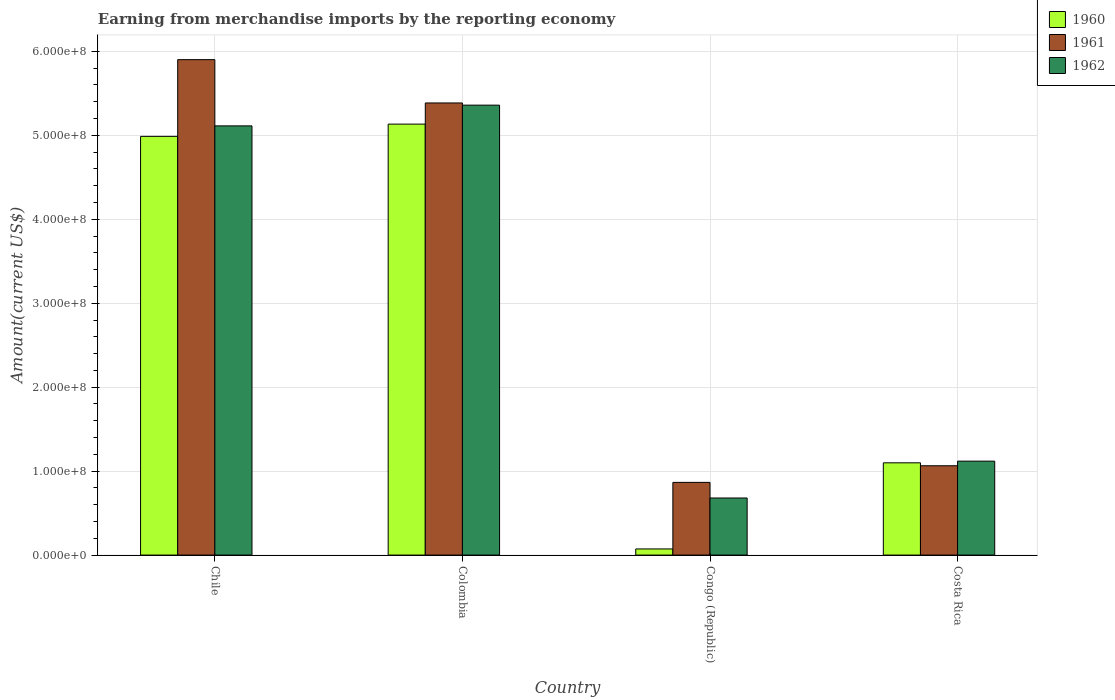How many bars are there on the 3rd tick from the left?
Provide a succinct answer. 3. What is the label of the 1st group of bars from the left?
Ensure brevity in your answer.  Chile. In how many cases, is the number of bars for a given country not equal to the number of legend labels?
Give a very brief answer. 0. What is the amount earned from merchandise imports in 1962 in Congo (Republic)?
Give a very brief answer. 6.80e+07. Across all countries, what is the maximum amount earned from merchandise imports in 1962?
Make the answer very short. 5.36e+08. Across all countries, what is the minimum amount earned from merchandise imports in 1962?
Offer a very short reply. 6.80e+07. In which country was the amount earned from merchandise imports in 1961 maximum?
Ensure brevity in your answer.  Chile. In which country was the amount earned from merchandise imports in 1962 minimum?
Offer a very short reply. Congo (Republic). What is the total amount earned from merchandise imports in 1962 in the graph?
Provide a short and direct response. 1.23e+09. What is the difference between the amount earned from merchandise imports in 1960 in Congo (Republic) and that in Costa Rica?
Offer a terse response. -1.03e+08. What is the difference between the amount earned from merchandise imports in 1962 in Costa Rica and the amount earned from merchandise imports in 1960 in Chile?
Offer a very short reply. -3.87e+08. What is the average amount earned from merchandise imports in 1961 per country?
Give a very brief answer. 3.30e+08. What is the difference between the amount earned from merchandise imports of/in 1962 and amount earned from merchandise imports of/in 1961 in Chile?
Keep it short and to the point. -7.89e+07. What is the ratio of the amount earned from merchandise imports in 1960 in Congo (Republic) to that in Costa Rica?
Ensure brevity in your answer.  0.07. Is the amount earned from merchandise imports in 1962 in Colombia less than that in Congo (Republic)?
Give a very brief answer. No. What is the difference between the highest and the second highest amount earned from merchandise imports in 1962?
Make the answer very short. 4.24e+08. What is the difference between the highest and the lowest amount earned from merchandise imports in 1962?
Provide a short and direct response. 4.68e+08. Is the sum of the amount earned from merchandise imports in 1960 in Colombia and Costa Rica greater than the maximum amount earned from merchandise imports in 1961 across all countries?
Give a very brief answer. Yes. What does the 1st bar from the left in Congo (Republic) represents?
Offer a terse response. 1960. What does the 2nd bar from the right in Chile represents?
Your answer should be compact. 1961. Is it the case that in every country, the sum of the amount earned from merchandise imports in 1961 and amount earned from merchandise imports in 1962 is greater than the amount earned from merchandise imports in 1960?
Make the answer very short. Yes. How many bars are there?
Give a very brief answer. 12. How many countries are there in the graph?
Make the answer very short. 4. Are the values on the major ticks of Y-axis written in scientific E-notation?
Make the answer very short. Yes. Does the graph contain grids?
Offer a terse response. Yes. How many legend labels are there?
Make the answer very short. 3. What is the title of the graph?
Keep it short and to the point. Earning from merchandise imports by the reporting economy. Does "1966" appear as one of the legend labels in the graph?
Provide a succinct answer. No. What is the label or title of the X-axis?
Make the answer very short. Country. What is the label or title of the Y-axis?
Make the answer very short. Amount(current US$). What is the Amount(current US$) in 1960 in Chile?
Your response must be concise. 4.99e+08. What is the Amount(current US$) of 1961 in Chile?
Keep it short and to the point. 5.90e+08. What is the Amount(current US$) in 1962 in Chile?
Make the answer very short. 5.11e+08. What is the Amount(current US$) in 1960 in Colombia?
Provide a succinct answer. 5.13e+08. What is the Amount(current US$) in 1961 in Colombia?
Your answer should be compact. 5.39e+08. What is the Amount(current US$) of 1962 in Colombia?
Make the answer very short. 5.36e+08. What is the Amount(current US$) in 1960 in Congo (Republic)?
Keep it short and to the point. 7.30e+06. What is the Amount(current US$) of 1961 in Congo (Republic)?
Provide a succinct answer. 8.66e+07. What is the Amount(current US$) of 1962 in Congo (Republic)?
Your answer should be compact. 6.80e+07. What is the Amount(current US$) in 1960 in Costa Rica?
Keep it short and to the point. 1.10e+08. What is the Amount(current US$) of 1961 in Costa Rica?
Ensure brevity in your answer.  1.06e+08. What is the Amount(current US$) in 1962 in Costa Rica?
Make the answer very short. 1.12e+08. Across all countries, what is the maximum Amount(current US$) of 1960?
Your response must be concise. 5.13e+08. Across all countries, what is the maximum Amount(current US$) of 1961?
Make the answer very short. 5.90e+08. Across all countries, what is the maximum Amount(current US$) in 1962?
Your answer should be compact. 5.36e+08. Across all countries, what is the minimum Amount(current US$) in 1960?
Make the answer very short. 7.30e+06. Across all countries, what is the minimum Amount(current US$) in 1961?
Your answer should be very brief. 8.66e+07. Across all countries, what is the minimum Amount(current US$) of 1962?
Your answer should be compact. 6.80e+07. What is the total Amount(current US$) in 1960 in the graph?
Your response must be concise. 1.13e+09. What is the total Amount(current US$) of 1961 in the graph?
Offer a terse response. 1.32e+09. What is the total Amount(current US$) of 1962 in the graph?
Your response must be concise. 1.23e+09. What is the difference between the Amount(current US$) of 1960 in Chile and that in Colombia?
Ensure brevity in your answer.  -1.46e+07. What is the difference between the Amount(current US$) of 1961 in Chile and that in Colombia?
Ensure brevity in your answer.  5.16e+07. What is the difference between the Amount(current US$) in 1962 in Chile and that in Colombia?
Ensure brevity in your answer.  -2.47e+07. What is the difference between the Amount(current US$) in 1960 in Chile and that in Congo (Republic)?
Provide a succinct answer. 4.92e+08. What is the difference between the Amount(current US$) of 1961 in Chile and that in Congo (Republic)?
Your answer should be very brief. 5.04e+08. What is the difference between the Amount(current US$) of 1962 in Chile and that in Congo (Republic)?
Give a very brief answer. 4.43e+08. What is the difference between the Amount(current US$) of 1960 in Chile and that in Costa Rica?
Your answer should be very brief. 3.89e+08. What is the difference between the Amount(current US$) of 1961 in Chile and that in Costa Rica?
Give a very brief answer. 4.84e+08. What is the difference between the Amount(current US$) in 1962 in Chile and that in Costa Rica?
Your answer should be very brief. 3.99e+08. What is the difference between the Amount(current US$) in 1960 in Colombia and that in Congo (Republic)?
Your answer should be compact. 5.06e+08. What is the difference between the Amount(current US$) of 1961 in Colombia and that in Congo (Republic)?
Keep it short and to the point. 4.52e+08. What is the difference between the Amount(current US$) of 1962 in Colombia and that in Congo (Republic)?
Offer a very short reply. 4.68e+08. What is the difference between the Amount(current US$) of 1960 in Colombia and that in Costa Rica?
Provide a succinct answer. 4.04e+08. What is the difference between the Amount(current US$) of 1961 in Colombia and that in Costa Rica?
Your response must be concise. 4.32e+08. What is the difference between the Amount(current US$) of 1962 in Colombia and that in Costa Rica?
Offer a very short reply. 4.24e+08. What is the difference between the Amount(current US$) of 1960 in Congo (Republic) and that in Costa Rica?
Ensure brevity in your answer.  -1.03e+08. What is the difference between the Amount(current US$) of 1961 in Congo (Republic) and that in Costa Rica?
Your response must be concise. -1.98e+07. What is the difference between the Amount(current US$) in 1962 in Congo (Republic) and that in Costa Rica?
Offer a very short reply. -4.39e+07. What is the difference between the Amount(current US$) in 1960 in Chile and the Amount(current US$) in 1961 in Colombia?
Offer a terse response. -3.98e+07. What is the difference between the Amount(current US$) of 1960 in Chile and the Amount(current US$) of 1962 in Colombia?
Your response must be concise. -3.72e+07. What is the difference between the Amount(current US$) in 1961 in Chile and the Amount(current US$) in 1962 in Colombia?
Make the answer very short. 5.42e+07. What is the difference between the Amount(current US$) in 1960 in Chile and the Amount(current US$) in 1961 in Congo (Republic)?
Provide a succinct answer. 4.12e+08. What is the difference between the Amount(current US$) in 1960 in Chile and the Amount(current US$) in 1962 in Congo (Republic)?
Provide a short and direct response. 4.31e+08. What is the difference between the Amount(current US$) in 1961 in Chile and the Amount(current US$) in 1962 in Congo (Republic)?
Offer a terse response. 5.22e+08. What is the difference between the Amount(current US$) in 1960 in Chile and the Amount(current US$) in 1961 in Costa Rica?
Give a very brief answer. 3.92e+08. What is the difference between the Amount(current US$) in 1960 in Chile and the Amount(current US$) in 1962 in Costa Rica?
Provide a short and direct response. 3.87e+08. What is the difference between the Amount(current US$) of 1961 in Chile and the Amount(current US$) of 1962 in Costa Rica?
Your answer should be compact. 4.78e+08. What is the difference between the Amount(current US$) of 1960 in Colombia and the Amount(current US$) of 1961 in Congo (Republic)?
Give a very brief answer. 4.27e+08. What is the difference between the Amount(current US$) in 1960 in Colombia and the Amount(current US$) in 1962 in Congo (Republic)?
Your answer should be very brief. 4.45e+08. What is the difference between the Amount(current US$) of 1961 in Colombia and the Amount(current US$) of 1962 in Congo (Republic)?
Offer a terse response. 4.71e+08. What is the difference between the Amount(current US$) of 1960 in Colombia and the Amount(current US$) of 1961 in Costa Rica?
Make the answer very short. 4.07e+08. What is the difference between the Amount(current US$) in 1960 in Colombia and the Amount(current US$) in 1962 in Costa Rica?
Offer a terse response. 4.02e+08. What is the difference between the Amount(current US$) of 1961 in Colombia and the Amount(current US$) of 1962 in Costa Rica?
Make the answer very short. 4.27e+08. What is the difference between the Amount(current US$) of 1960 in Congo (Republic) and the Amount(current US$) of 1961 in Costa Rica?
Your answer should be compact. -9.91e+07. What is the difference between the Amount(current US$) in 1960 in Congo (Republic) and the Amount(current US$) in 1962 in Costa Rica?
Offer a terse response. -1.05e+08. What is the difference between the Amount(current US$) of 1961 in Congo (Republic) and the Amount(current US$) of 1962 in Costa Rica?
Offer a very short reply. -2.53e+07. What is the average Amount(current US$) of 1960 per country?
Give a very brief answer. 2.82e+08. What is the average Amount(current US$) in 1961 per country?
Provide a succinct answer. 3.30e+08. What is the average Amount(current US$) of 1962 per country?
Provide a short and direct response. 3.07e+08. What is the difference between the Amount(current US$) of 1960 and Amount(current US$) of 1961 in Chile?
Provide a succinct answer. -9.14e+07. What is the difference between the Amount(current US$) in 1960 and Amount(current US$) in 1962 in Chile?
Offer a very short reply. -1.25e+07. What is the difference between the Amount(current US$) of 1961 and Amount(current US$) of 1962 in Chile?
Your answer should be compact. 7.89e+07. What is the difference between the Amount(current US$) in 1960 and Amount(current US$) in 1961 in Colombia?
Your response must be concise. -2.52e+07. What is the difference between the Amount(current US$) in 1960 and Amount(current US$) in 1962 in Colombia?
Your response must be concise. -2.26e+07. What is the difference between the Amount(current US$) of 1961 and Amount(current US$) of 1962 in Colombia?
Your answer should be compact. 2.60e+06. What is the difference between the Amount(current US$) in 1960 and Amount(current US$) in 1961 in Congo (Republic)?
Your answer should be compact. -7.93e+07. What is the difference between the Amount(current US$) of 1960 and Amount(current US$) of 1962 in Congo (Republic)?
Your response must be concise. -6.07e+07. What is the difference between the Amount(current US$) in 1961 and Amount(current US$) in 1962 in Congo (Republic)?
Your answer should be very brief. 1.86e+07. What is the difference between the Amount(current US$) in 1960 and Amount(current US$) in 1961 in Costa Rica?
Keep it short and to the point. 3.50e+06. What is the difference between the Amount(current US$) of 1961 and Amount(current US$) of 1962 in Costa Rica?
Make the answer very short. -5.50e+06. What is the ratio of the Amount(current US$) in 1960 in Chile to that in Colombia?
Provide a succinct answer. 0.97. What is the ratio of the Amount(current US$) in 1961 in Chile to that in Colombia?
Make the answer very short. 1.1. What is the ratio of the Amount(current US$) of 1962 in Chile to that in Colombia?
Give a very brief answer. 0.95. What is the ratio of the Amount(current US$) in 1960 in Chile to that in Congo (Republic)?
Your answer should be very brief. 68.33. What is the ratio of the Amount(current US$) in 1961 in Chile to that in Congo (Republic)?
Provide a succinct answer. 6.82. What is the ratio of the Amount(current US$) of 1962 in Chile to that in Congo (Republic)?
Offer a very short reply. 7.52. What is the ratio of the Amount(current US$) of 1960 in Chile to that in Costa Rica?
Offer a very short reply. 4.54. What is the ratio of the Amount(current US$) of 1961 in Chile to that in Costa Rica?
Offer a terse response. 5.55. What is the ratio of the Amount(current US$) in 1962 in Chile to that in Costa Rica?
Your answer should be compact. 4.57. What is the ratio of the Amount(current US$) in 1960 in Colombia to that in Congo (Republic)?
Your answer should be very brief. 70.33. What is the ratio of the Amount(current US$) of 1961 in Colombia to that in Congo (Republic)?
Your answer should be compact. 6.22. What is the ratio of the Amount(current US$) in 1962 in Colombia to that in Congo (Republic)?
Make the answer very short. 7.88. What is the ratio of the Amount(current US$) in 1960 in Colombia to that in Costa Rica?
Your answer should be compact. 4.67. What is the ratio of the Amount(current US$) of 1961 in Colombia to that in Costa Rica?
Offer a terse response. 5.06. What is the ratio of the Amount(current US$) in 1962 in Colombia to that in Costa Rica?
Offer a very short reply. 4.79. What is the ratio of the Amount(current US$) in 1960 in Congo (Republic) to that in Costa Rica?
Provide a succinct answer. 0.07. What is the ratio of the Amount(current US$) in 1961 in Congo (Republic) to that in Costa Rica?
Keep it short and to the point. 0.81. What is the ratio of the Amount(current US$) in 1962 in Congo (Republic) to that in Costa Rica?
Ensure brevity in your answer.  0.61. What is the difference between the highest and the second highest Amount(current US$) of 1960?
Offer a very short reply. 1.46e+07. What is the difference between the highest and the second highest Amount(current US$) in 1961?
Provide a short and direct response. 5.16e+07. What is the difference between the highest and the second highest Amount(current US$) in 1962?
Make the answer very short. 2.47e+07. What is the difference between the highest and the lowest Amount(current US$) of 1960?
Your answer should be compact. 5.06e+08. What is the difference between the highest and the lowest Amount(current US$) of 1961?
Give a very brief answer. 5.04e+08. What is the difference between the highest and the lowest Amount(current US$) of 1962?
Ensure brevity in your answer.  4.68e+08. 